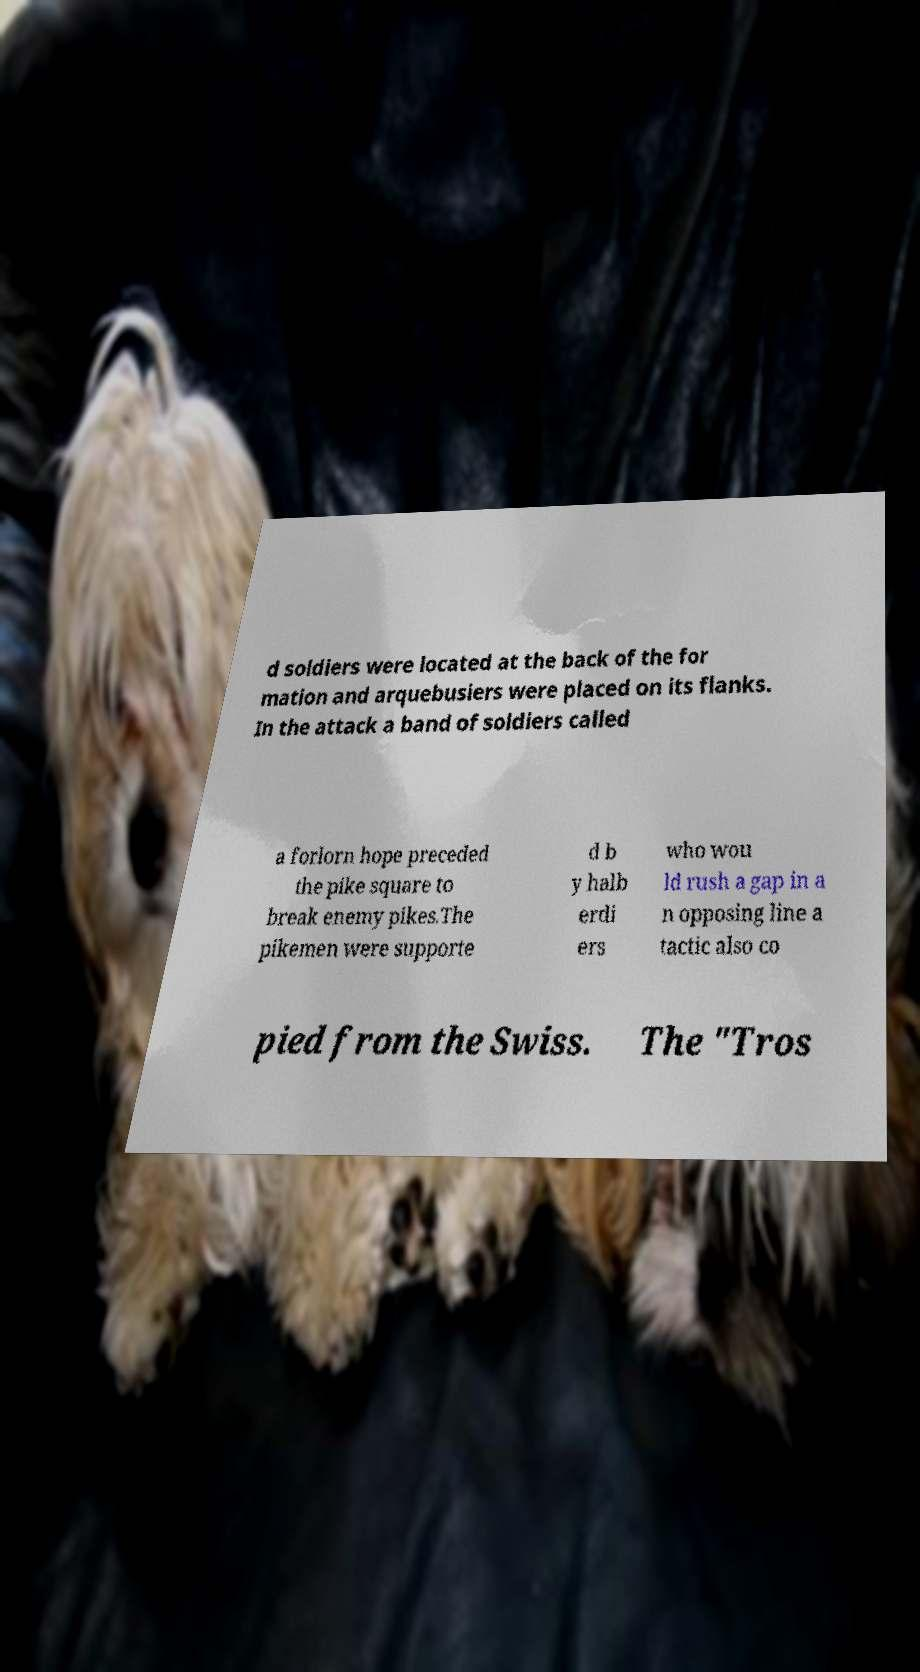I need the written content from this picture converted into text. Can you do that? d soldiers were located at the back of the for mation and arquebusiers were placed on its flanks. In the attack a band of soldiers called a forlorn hope preceded the pike square to break enemy pikes.The pikemen were supporte d b y halb erdi ers who wou ld rush a gap in a n opposing line a tactic also co pied from the Swiss. The "Tros 